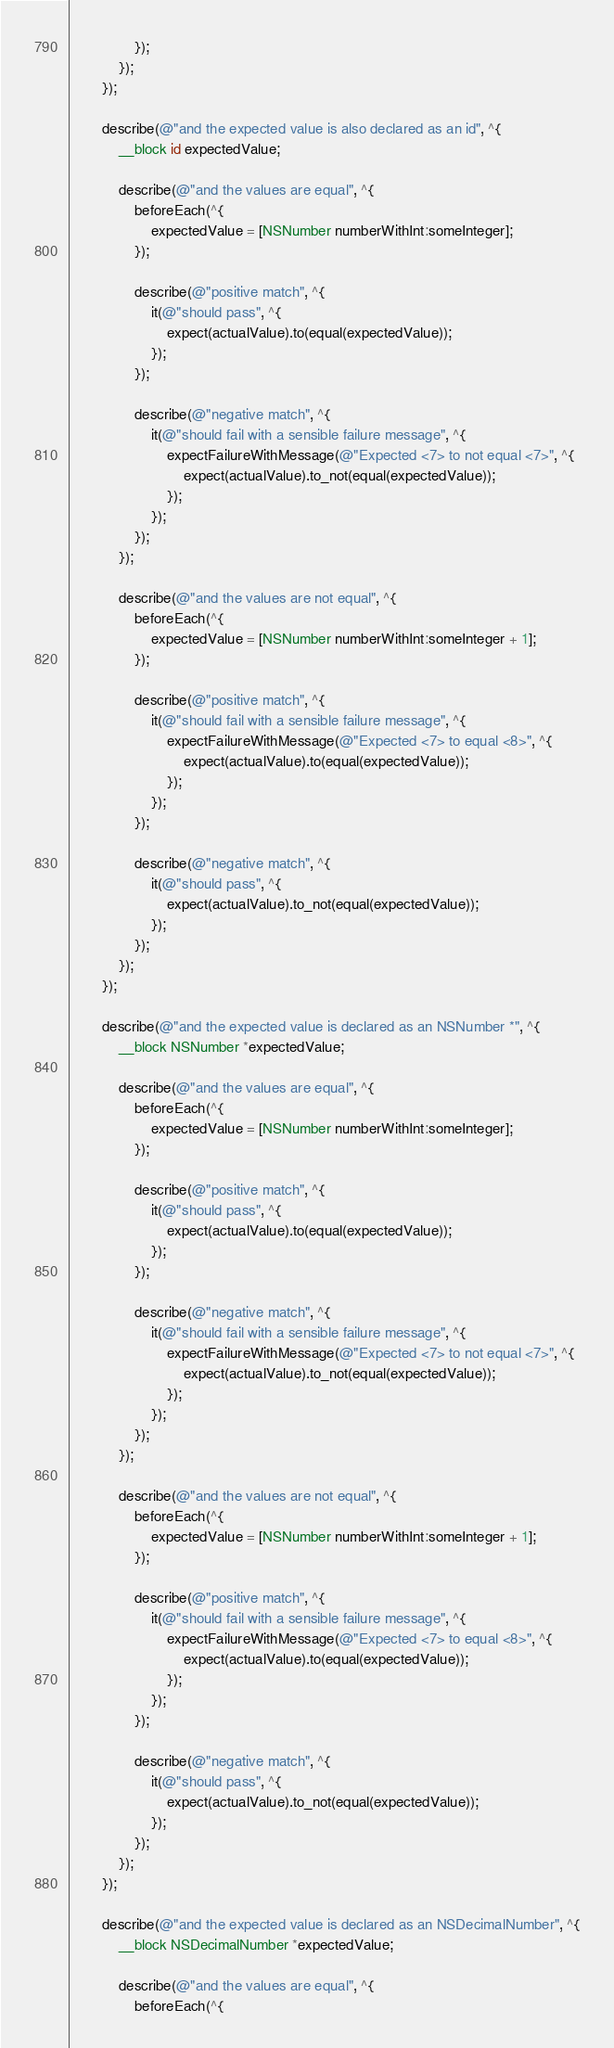<code> <loc_0><loc_0><loc_500><loc_500><_ObjectiveC_>                });
            });
        });

        describe(@"and the expected value is also declared as an id", ^{
            __block id expectedValue;

            describe(@"and the values are equal", ^{
                beforeEach(^{
                    expectedValue = [NSNumber numberWithInt:someInteger];
                });

                describe(@"positive match", ^{
                    it(@"should pass", ^{
                        expect(actualValue).to(equal(expectedValue));
                    });
                });

                describe(@"negative match", ^{
                    it(@"should fail with a sensible failure message", ^{
                        expectFailureWithMessage(@"Expected <7> to not equal <7>", ^{
                            expect(actualValue).to_not(equal(expectedValue));
                        });
                    });
                });
            });

            describe(@"and the values are not equal", ^{
                beforeEach(^{
                    expectedValue = [NSNumber numberWithInt:someInteger + 1];
                });

                describe(@"positive match", ^{
                    it(@"should fail with a sensible failure message", ^{
                        expectFailureWithMessage(@"Expected <7> to equal <8>", ^{
                            expect(actualValue).to(equal(expectedValue));
                        });
                    });
                });

                describe(@"negative match", ^{
                    it(@"should pass", ^{
                        expect(actualValue).to_not(equal(expectedValue));
                    });
                });
            });
        });

        describe(@"and the expected value is declared as an NSNumber *", ^{
            __block NSNumber *expectedValue;

            describe(@"and the values are equal", ^{
                beforeEach(^{
                    expectedValue = [NSNumber numberWithInt:someInteger];
                });

                describe(@"positive match", ^{
                    it(@"should pass", ^{
                        expect(actualValue).to(equal(expectedValue));
                    });
                });

                describe(@"negative match", ^{
                    it(@"should fail with a sensible failure message", ^{
                        expectFailureWithMessage(@"Expected <7> to not equal <7>", ^{
                            expect(actualValue).to_not(equal(expectedValue));
                        });
                    });
                });
            });

            describe(@"and the values are not equal", ^{
                beforeEach(^{
                    expectedValue = [NSNumber numberWithInt:someInteger + 1];
                });

                describe(@"positive match", ^{
                    it(@"should fail with a sensible failure message", ^{
                        expectFailureWithMessage(@"Expected <7> to equal <8>", ^{
                            expect(actualValue).to(equal(expectedValue));
                        });
                    });
                });

                describe(@"negative match", ^{
                    it(@"should pass", ^{
                        expect(actualValue).to_not(equal(expectedValue));
                    });
                });
            });
        });

        describe(@"and the expected value is declared as an NSDecimalNumber", ^{
            __block NSDecimalNumber *expectedValue;

            describe(@"and the values are equal", ^{
                beforeEach(^{</code> 